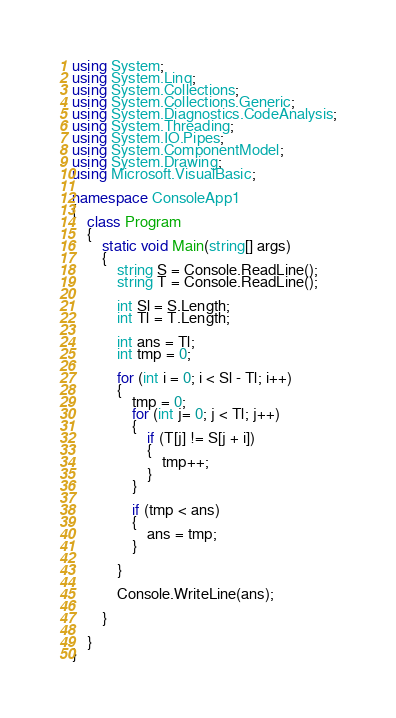Convert code to text. <code><loc_0><loc_0><loc_500><loc_500><_C#_>using System;
using System.Linq;
using System.Collections;
using System.Collections.Generic;
using System.Diagnostics.CodeAnalysis;
using System.Threading;
using System.IO.Pipes;
using System.ComponentModel;
using System.Drawing;
using Microsoft.VisualBasic;

namespace ConsoleApp1
{
    class Program
    {
        static void Main(string[] args)
        {
            string S = Console.ReadLine();
            string T = Console.ReadLine();

            int Sl = S.Length;
            int Tl = T.Length;

            int ans = Tl;
            int tmp = 0;

            for (int i = 0; i < Sl - Tl; i++) 
            {
                tmp = 0;
                for (int j= 0; j < Tl; j++)
                {
                    if (T[j] != S[j + i]) 
                    {
                        tmp++;
                    } 
                }

                if (tmp < ans) 
                {
                    ans = tmp;
                }

            }

            Console.WriteLine(ans);

        }

    }
}
</code> 